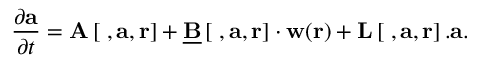Convert formula to latex. <formula><loc_0><loc_0><loc_500><loc_500>\frac { \partial a } { \partial t } = A \left [ \nabla , a , r \right ] + \underline { B } \left [ \nabla , a , r \right ] \cdot w ( r ) + L \left [ \nabla , a , r \right ] . a .</formula> 